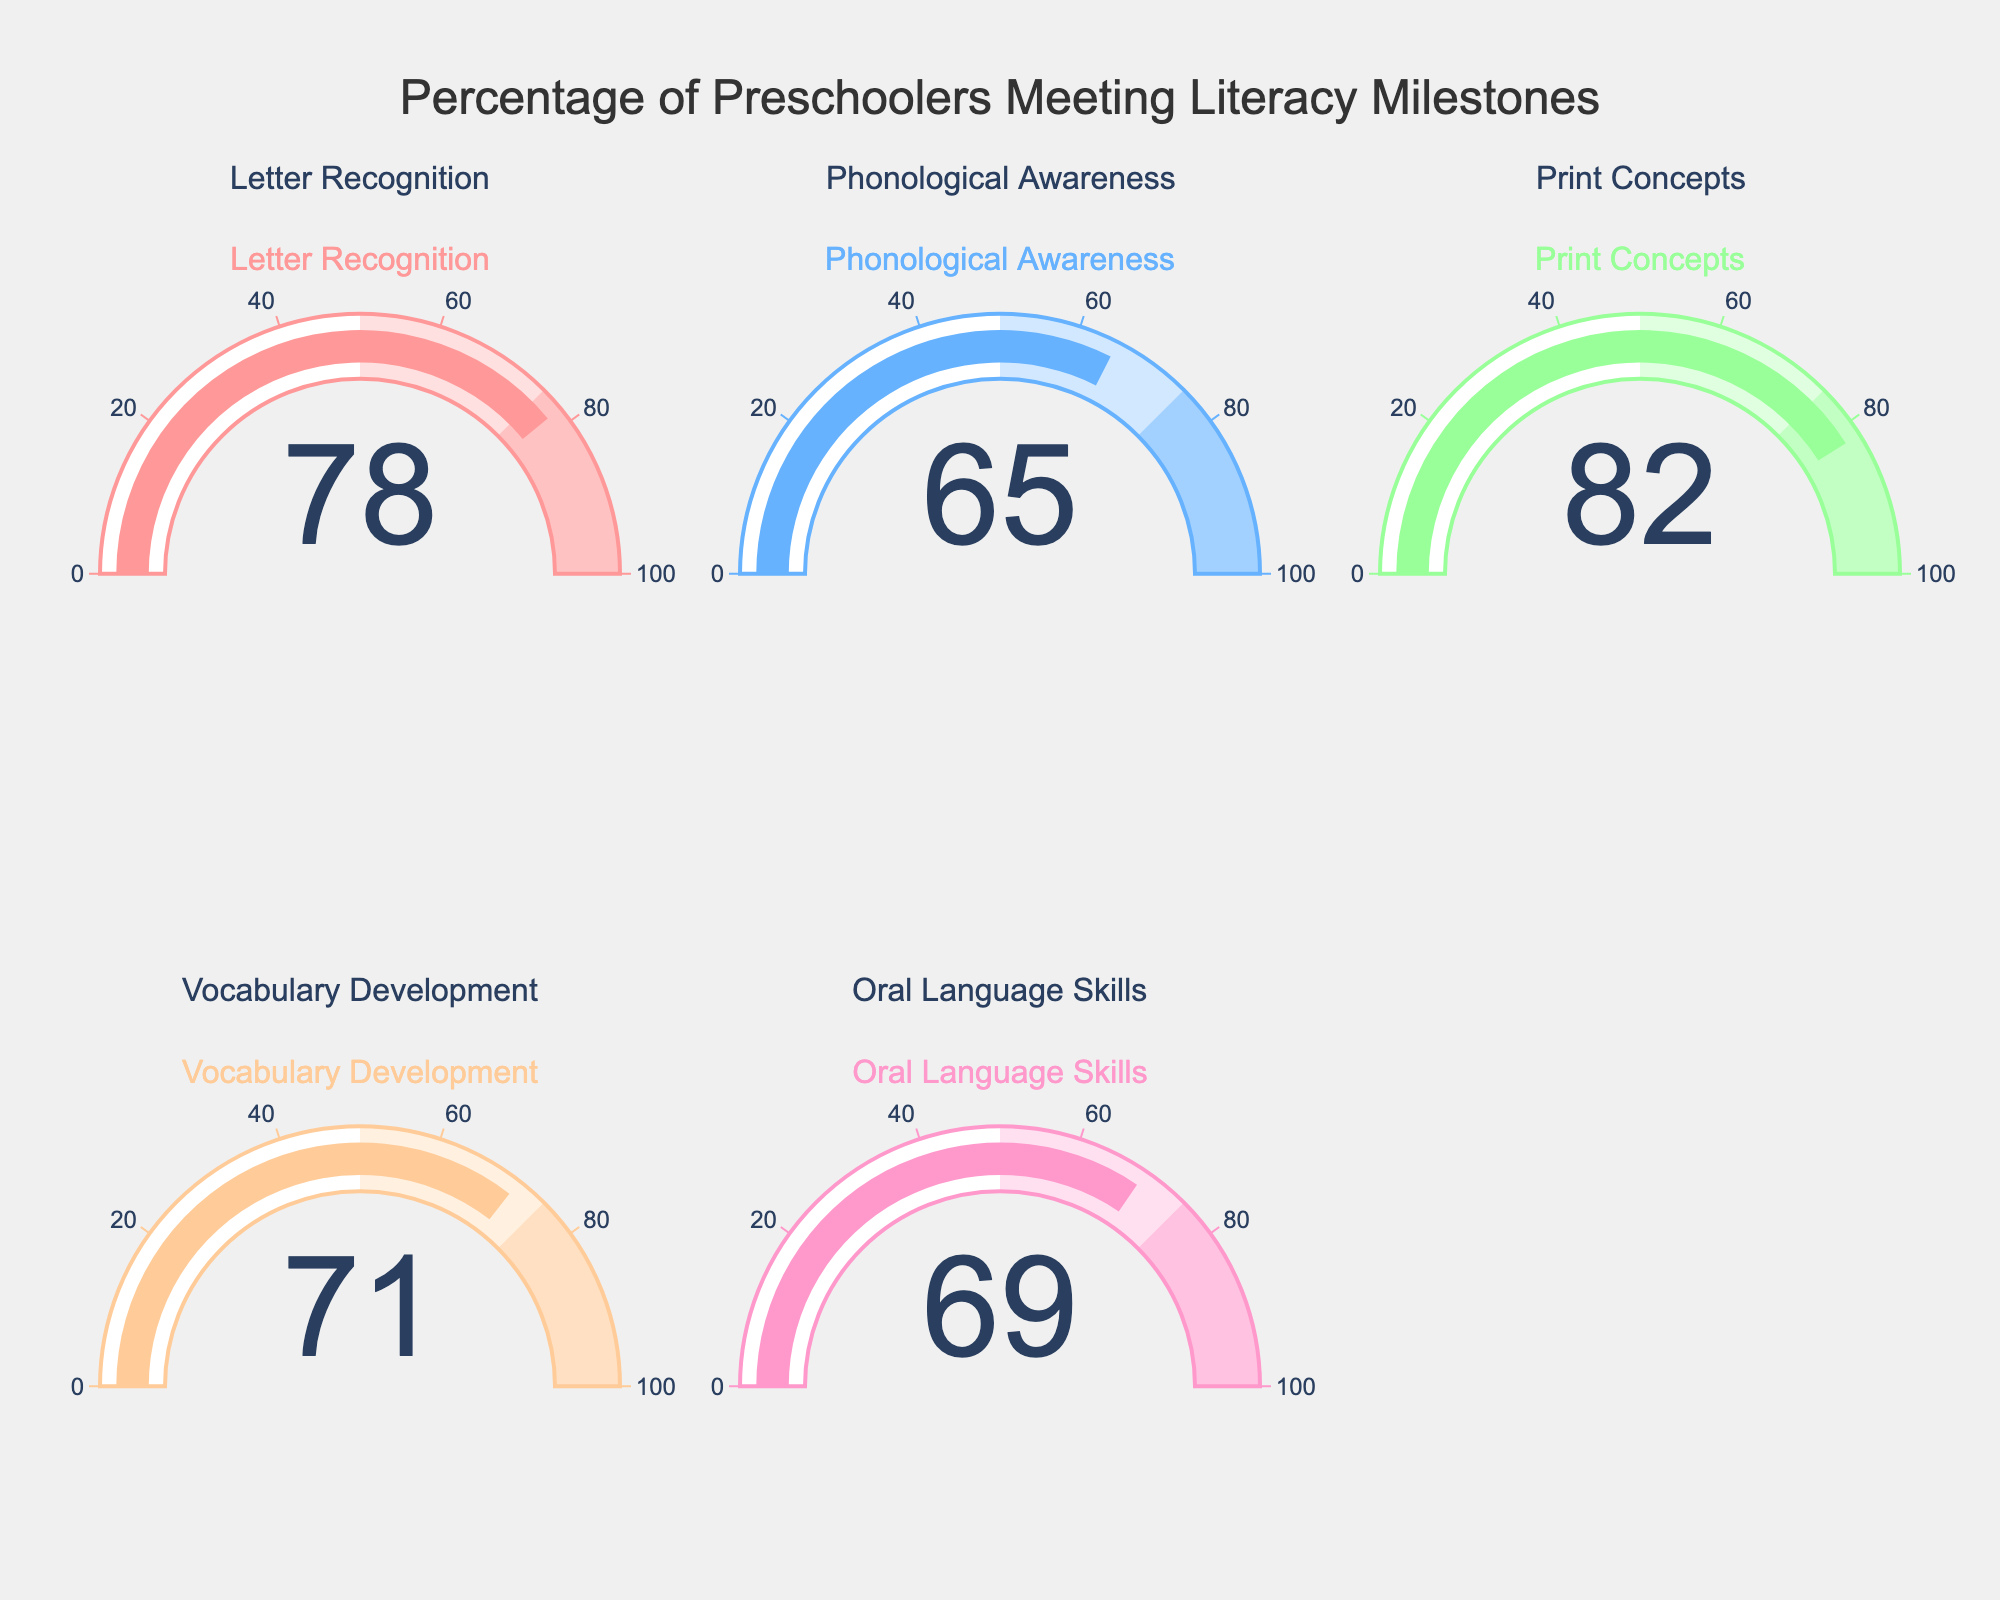What is the main title of the chart? The title is placed at the top center of the chart. It typically describes the purpose or content of the figure.
Answer: Percentage of Preschoolers Meeting Literacy Milestones Which literacy milestone has the highest percentage? To find the highest percentage, look for the gauge that indicates the largest number. In this case, the "Print Concepts" gauge shows 82%, which is the highest.
Answer: Print Concepts What is the average percentage of preschoolers meeting the listed literacy milestones? To find the average, add all percentages and divide by the number of categories. (78 + 65 + 82 + 71 + 69) / 5 = 365 / 5 = 73
Answer: 73 How many categories have a percentage greater than 70? Count the categories with percentages above 70%. They are: "Letter Recognition" (78%), "Print Concepts" (82%), and "Vocabulary Development" (71%).
Answer: 3 Which literacy milestone has the lowest percentage? Look for the lowest percentage value on the gauges. Here, the "Phonological Awareness" gauge shows 65%, which is the smallest percentage.
Answer: Phonological Awareness Compare the percentage of preschoolers meeting the "Oral Language Skills" milestone to those meeting the "Vocabulary Development" milestone. Which is higher and by how much? "Vocabulary Development" is 71% while "Oral Language Skills" is 69%. Calculate the difference (71 - 69) to see that "Vocabulary Development" is 2% higher.
Answer: Vocabulary Development by 2% What is the median percentage of the literacy milestones? To find the median, arrange percentages in ascending order and pick the middle value. Ordered: 65, 69, 71, 78, 82. The middle value is 71.
Answer: 71 If you combine the percentages of "Phonological Awareness" and "Print Concepts," what is the total? Simply add the percentages of these two categories together: 65 + 82 = 147.
Answer: 147 Which category's gauge bar color is pink? Identify the color of the gauge bar associated with each category. The "Letter Recognition," with a percentage of 78%, is shown with a pink bar.
Answer: Letter Recognition 